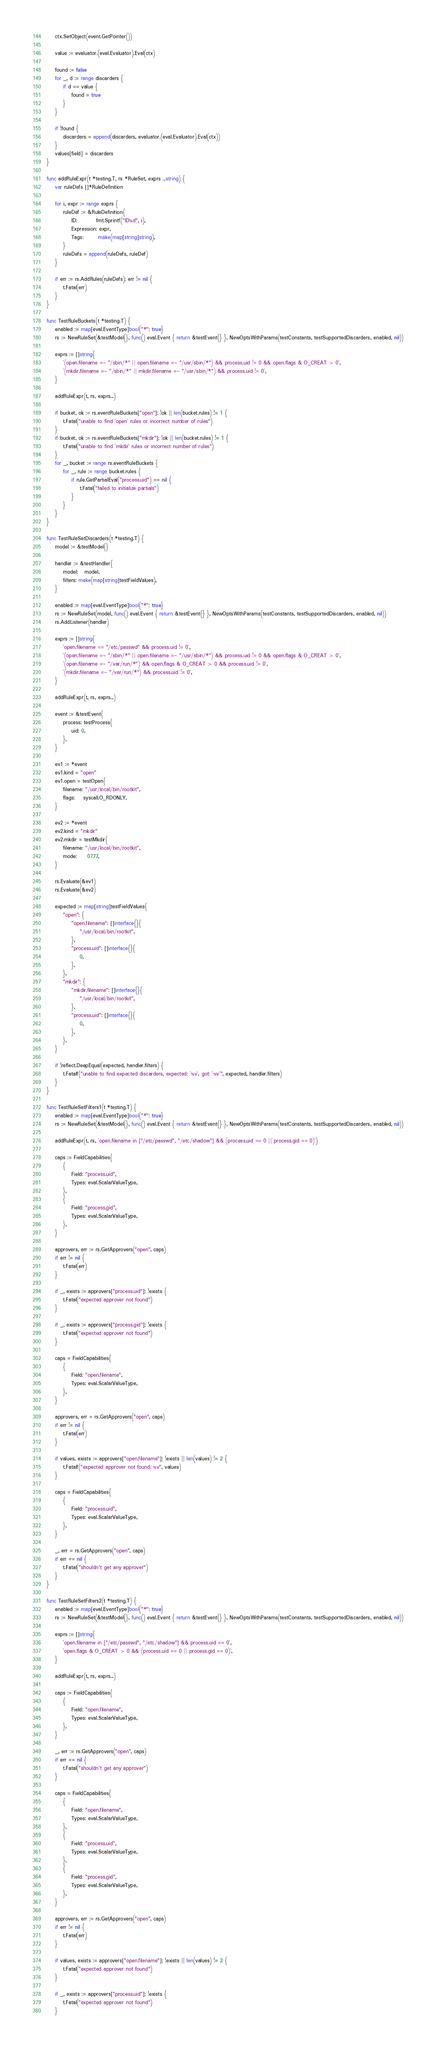Convert code to text. <code><loc_0><loc_0><loc_500><loc_500><_Go_>	ctx.SetObject(event.GetPointer())

	value := evaluator.(eval.Evaluator).Eval(ctx)

	found := false
	for _, d := range discarders {
		if d == value {
			found = true
		}
	}

	if !found {
		discarders = append(discarders, evaluator.(eval.Evaluator).Eval(ctx))
	}
	values[field] = discarders
}

func addRuleExpr(t *testing.T, rs *RuleSet, exprs ...string) {
	var ruleDefs []*RuleDefinition

	for i, expr := range exprs {
		ruleDef := &RuleDefinition{
			ID:         fmt.Sprintf("ID%d", i),
			Expression: expr,
			Tags:       make(map[string]string),
		}
		ruleDefs = append(ruleDefs, ruleDef)
	}

	if err := rs.AddRules(ruleDefs); err != nil {
		t.Fatal(err)
	}
}

func TestRuleBuckets(t *testing.T) {
	enabled := map[eval.EventType]bool{"*": true}
	rs := NewRuleSet(&testModel{}, func() eval.Event { return &testEvent{} }, NewOptsWithParams(testConstants, testSupportedDiscarders, enabled, nil))

	exprs := []string{
		`(open.filename =~ "/sbin/*" || open.filename =~ "/usr/sbin/*") && process.uid != 0 && open.flags & O_CREAT > 0`,
		`(mkdir.filename =~ "/sbin/*" || mkdir.filename =~ "/usr/sbin/*") && process.uid != 0`,
	}

	addRuleExpr(t, rs, exprs...)

	if bucket, ok := rs.eventRuleBuckets["open"]; !ok || len(bucket.rules) != 1 {
		t.Fatal("unable to find `open` rules or incorrect number of rules")
	}
	if bucket, ok := rs.eventRuleBuckets["mkdir"]; !ok || len(bucket.rules) != 1 {
		t.Fatal("unable to find `mkdir` rules or incorrect number of rules")
	}
	for _, bucket := range rs.eventRuleBuckets {
		for _, rule := range bucket.rules {
			if rule.GetPartialEval("process.uid") == nil {
				t.Fatal("failed to initialize partials")
			}
		}
	}
}

func TestRuleSetDiscarders(t *testing.T) {
	model := &testModel{}

	handler := &testHandler{
		model:   model,
		filters: make(map[string]testFieldValues),
	}

	enabled := map[eval.EventType]bool{"*": true}
	rs := NewRuleSet(model, func() eval.Event { return &testEvent{} }, NewOptsWithParams(testConstants, testSupportedDiscarders, enabled, nil))
	rs.AddListener(handler)

	exprs := []string{
		`open.filename == "/etc/passwd" && process.uid != 0`,
		`(open.filename =~ "/sbin/*" || open.filename =~ "/usr/sbin/*") && process.uid != 0 && open.flags & O_CREAT > 0`,
		`(open.filename =~ "/var/run/*") && open.flags & O_CREAT > 0 && process.uid != 0`,
		`(mkdir.filename =~ "/var/run/*") && process.uid != 0`,
	}

	addRuleExpr(t, rs, exprs...)

	event := &testEvent{
		process: testProcess{
			uid: 0,
		},
	}

	ev1 := *event
	ev1.kind = "open"
	ev1.open = testOpen{
		filename: "/usr/local/bin/rootkit",
		flags:    syscall.O_RDONLY,
	}

	ev2 := *event
	ev2.kind = "mkdir"
	ev2.mkdir = testMkdir{
		filename: "/usr/local/bin/rootkit",
		mode:     0777,
	}

	rs.Evaluate(&ev1)
	rs.Evaluate(&ev2)

	expected := map[string]testFieldValues{
		"open": {
			"open.filename": []interface{}{
				"/usr/local/bin/rootkit",
			},
			"process.uid": []interface{}{
				0,
			},
		},
		"mkdir": {
			"mkdir.filename": []interface{}{
				"/usr/local/bin/rootkit",
			},
			"process.uid": []interface{}{
				0,
			},
		},
	}

	if !reflect.DeepEqual(expected, handler.filters) {
		t.Fatalf("unable to find expected discarders, expected: `%v`, got: `%v`", expected, handler.filters)
	}
}

func TestRuleSetFilters1(t *testing.T) {
	enabled := map[eval.EventType]bool{"*": true}
	rs := NewRuleSet(&testModel{}, func() eval.Event { return &testEvent{} }, NewOptsWithParams(testConstants, testSupportedDiscarders, enabled, nil))

	addRuleExpr(t, rs, `open.filename in ["/etc/passwd", "/etc/shadow"] && (process.uid == 0 || process.gid == 0)`)

	caps := FieldCapabilities{
		{
			Field: "process.uid",
			Types: eval.ScalarValueType,
		},
		{
			Field: "process.gid",
			Types: eval.ScalarValueType,
		},
	}

	approvers, err := rs.GetApprovers("open", caps)
	if err != nil {
		t.Fatal(err)
	}

	if _, exists := approvers["process.uid"]; !exists {
		t.Fatal("expected approver not found")
	}

	if _, exists := approvers["process.gid"]; !exists {
		t.Fatal("expected approver not found")
	}

	caps = FieldCapabilities{
		{
			Field: "open.filename",
			Types: eval.ScalarValueType,
		},
	}

	approvers, err = rs.GetApprovers("open", caps)
	if err != nil {
		t.Fatal(err)
	}

	if values, exists := approvers["open.filename"]; !exists || len(values) != 2 {
		t.Fatalf("expected approver not found: %v", values)
	}

	caps = FieldCapabilities{
		{
			Field: "process.uid",
			Types: eval.ScalarValueType,
		},
	}

	_, err = rs.GetApprovers("open", caps)
	if err == nil {
		t.Fatal("shouldn't get any approver")
	}
}

func TestRuleSetFilters2(t *testing.T) {
	enabled := map[eval.EventType]bool{"*": true}
	rs := NewRuleSet(&testModel{}, func() eval.Event { return &testEvent{} }, NewOptsWithParams(testConstants, testSupportedDiscarders, enabled, nil))

	exprs := []string{
		`open.filename in ["/etc/passwd", "/etc/shadow"] && process.uid == 0`,
		`open.flags & O_CREAT > 0 && (process.uid == 0 || process.gid == 0)`,
	}

	addRuleExpr(t, rs, exprs...)

	caps := FieldCapabilities{
		{
			Field: "open.filename",
			Types: eval.ScalarValueType,
		},
	}

	_, err := rs.GetApprovers("open", caps)
	if err == nil {
		t.Fatal("shouldn't get any approver")
	}

	caps = FieldCapabilities{
		{
			Field: "open.filename",
			Types: eval.ScalarValueType,
		},
		{
			Field: "process.uid",
			Types: eval.ScalarValueType,
		},
		{
			Field: "process.gid",
			Types: eval.ScalarValueType,
		},
	}

	approvers, err := rs.GetApprovers("open", caps)
	if err != nil {
		t.Fatal(err)
	}

	if values, exists := approvers["open.filename"]; !exists || len(values) != 2 {
		t.Fatal("expected approver not found")
	}

	if _, exists := approvers["process.uid"]; !exists {
		t.Fatal("expected approver not found")
	}
</code> 